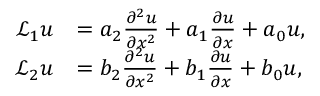Convert formula to latex. <formula><loc_0><loc_0><loc_500><loc_500>\begin{array} { r l } { \mathcal { L } _ { 1 } u } & { = a _ { 2 } \frac { \partial ^ { 2 } u } { \partial x ^ { 2 } } + a _ { 1 } \frac { \partial u } { \partial x } + a _ { 0 } u , } \\ { \mathcal { L } _ { 2 } u } & { = b _ { 2 } \frac { \partial ^ { 2 } u } { \partial x ^ { 2 } } + b _ { 1 } \frac { \partial u } { \partial x } + b _ { 0 } u , } \end{array}</formula> 